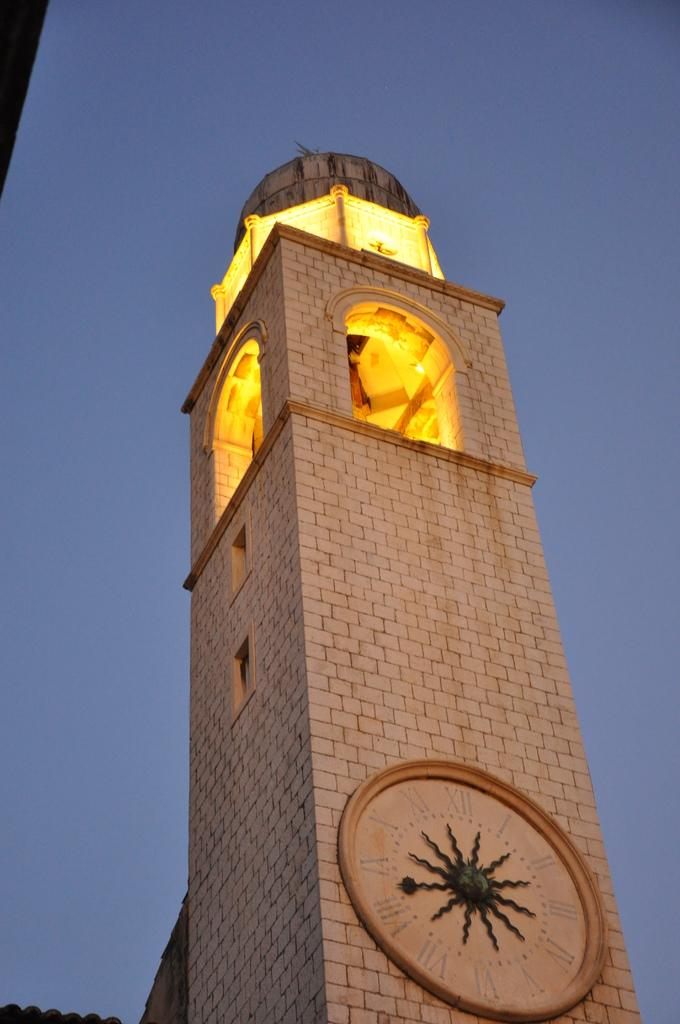What is the main structure in the image? There is a lighthouse in the image. What can be seen in the background of the image? The sky is visible in the image. How many letters are visible on the lighthouse in the image? There are no letters visible on the lighthouse in the image. What type of quartz can be seen in the image? There is no quartz present in the image. 